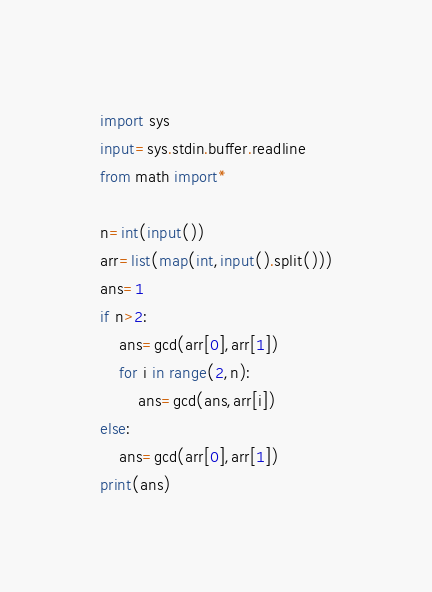<code> <loc_0><loc_0><loc_500><loc_500><_Python_>import sys
input=sys.stdin.buffer.readline
from math import*

n=int(input())
arr=list(map(int,input().split()))
ans=1
if n>2:
	ans=gcd(arr[0],arr[1])
	for i in range(2,n):
		ans=gcd(ans,arr[i])
else:
	ans=gcd(arr[0],arr[1])
print(ans)</code> 